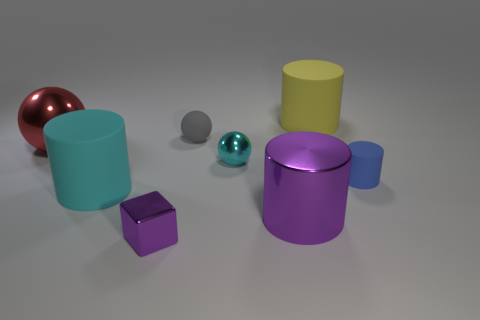Subtract all small rubber cylinders. How many cylinders are left? 3 Subtract all blue cylinders. How many cylinders are left? 3 Subtract 3 cylinders. How many cylinders are left? 1 Add 1 large yellow metal cylinders. How many objects exist? 9 Subtract 1 gray spheres. How many objects are left? 7 Subtract all blocks. How many objects are left? 7 Subtract all green blocks. Subtract all red cylinders. How many blocks are left? 1 Subtract all green spheres. How many yellow cylinders are left? 1 Subtract all large purple objects. Subtract all cyan rubber cylinders. How many objects are left? 6 Add 3 rubber cylinders. How many rubber cylinders are left? 6 